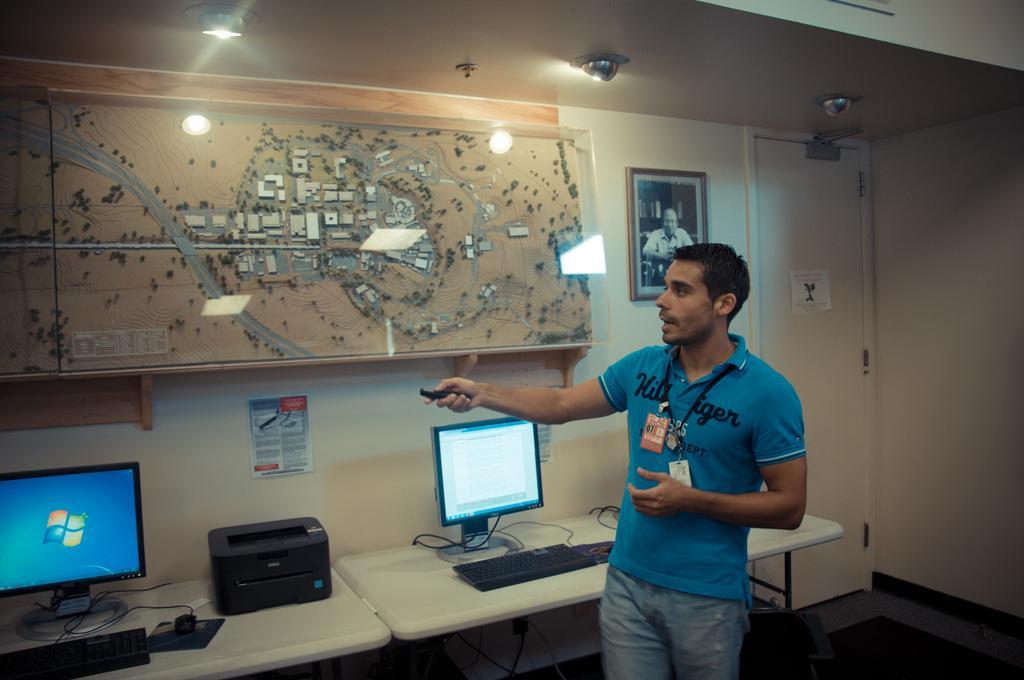Please provide a concise description of this image. This picture shows couple of monitors, printers and keyboards and a mouse on the tables and we see a poster on the wall and see man standing and holding a torch in his hand and speaking. He wore ID cards and we see a map on the wall and a photo frame and couple of lights to the roof and we see a door. 